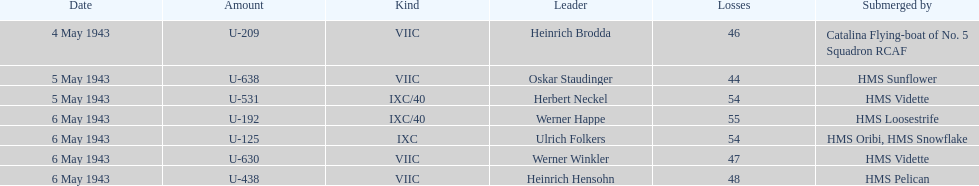What was the only captain sunk by hms pelican? Heinrich Hensohn. 